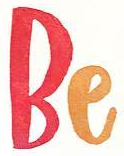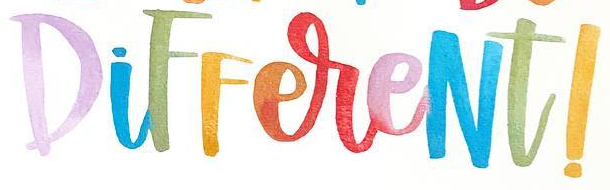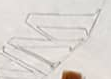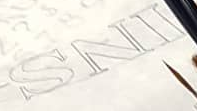What words can you see in these images in sequence, separated by a semicolon? Be; DiFFereNt!; W; INS 